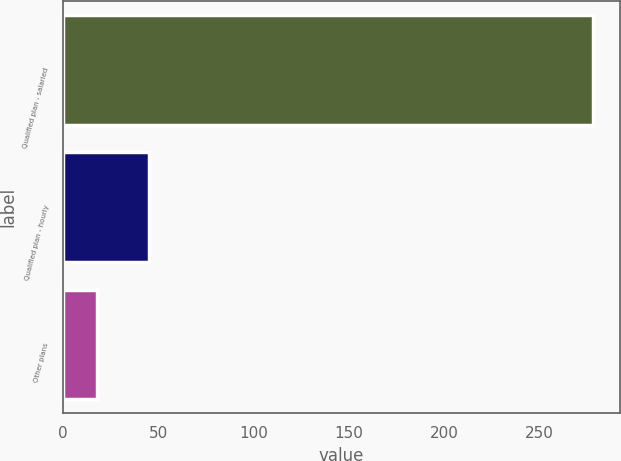Convert chart. <chart><loc_0><loc_0><loc_500><loc_500><bar_chart><fcel>Qualified plan - salaried<fcel>Qualified plan - hourly<fcel>Other plans<nl><fcel>278<fcel>45<fcel>18<nl></chart> 